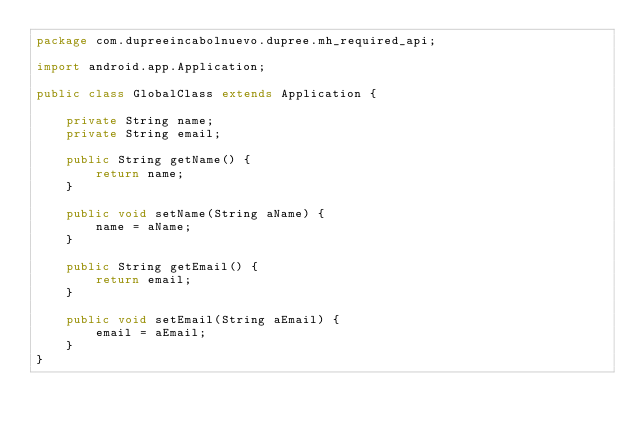Convert code to text. <code><loc_0><loc_0><loc_500><loc_500><_Java_>package com.dupreeincabolnuevo.dupree.mh_required_api;

import android.app.Application;

public class GlobalClass extends Application {

    private String name;
    private String email;

    public String getName() {
        return name;
    }

    public void setName(String aName) {
        name = aName;
    }

    public String getEmail() {
        return email;
    }

    public void setEmail(String aEmail) {
        email = aEmail;
    }
}
</code> 